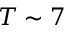Convert formula to latex. <formula><loc_0><loc_0><loc_500><loc_500>T \sim 7</formula> 